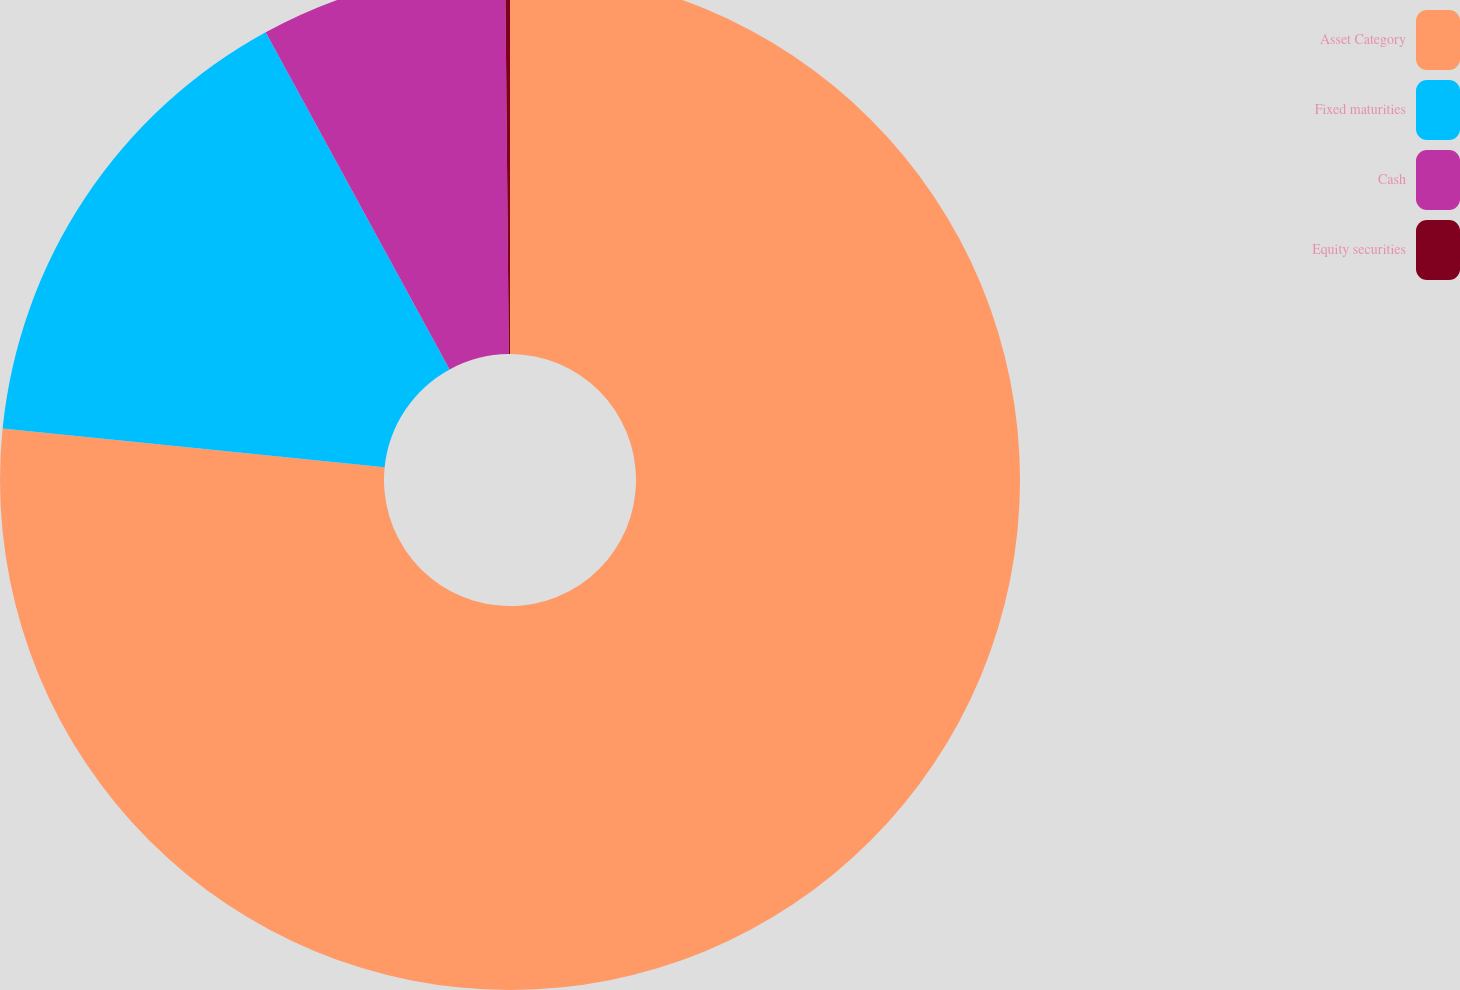Convert chart. <chart><loc_0><loc_0><loc_500><loc_500><pie_chart><fcel>Asset Category<fcel>Fixed maturities<fcel>Cash<fcel>Equity securities<nl><fcel>76.61%<fcel>15.44%<fcel>7.8%<fcel>0.15%<nl></chart> 